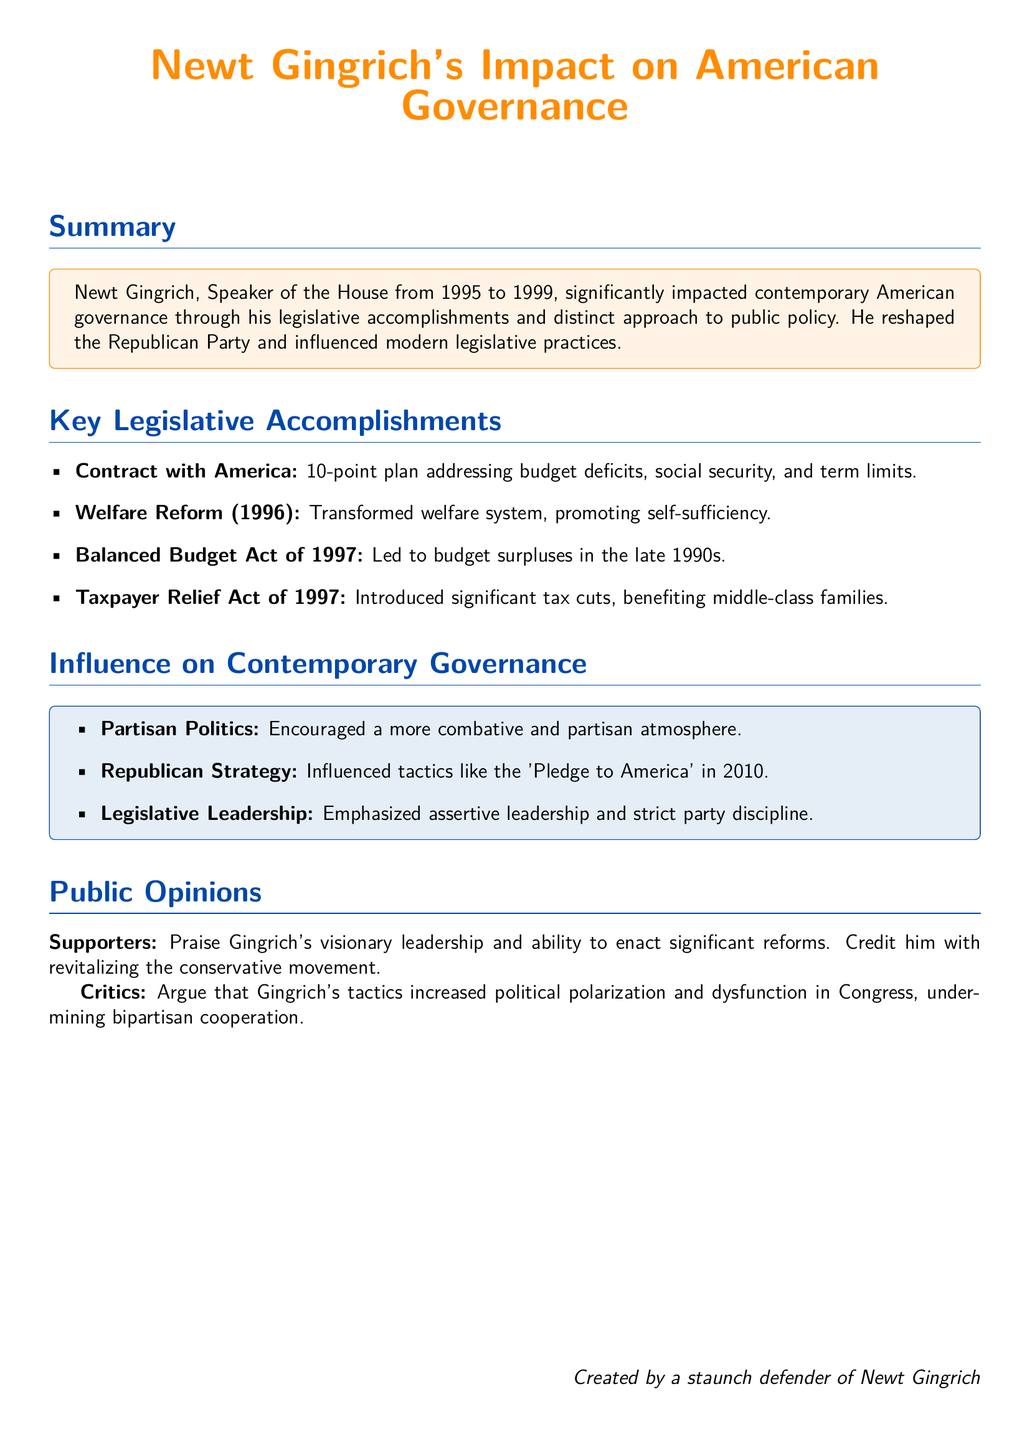What is Newt Gingrich's role? The document states that Newt Gingrich was the Speaker of the House from 1995 to 1999.
Answer: Speaker of the House What is the first legislative accomplishment listed? The first legislative accomplishment mentioned is the "Contract with America", a 10-point plan addressing key issues.
Answer: Contract with America What year was the Welfare Reform enacted? The document specifies that the Welfare Reform was enacted in 1996.
Answer: 1996 What significant act did Gingrich lead in 1997 that contributed to budget surpluses? The document mentions the Balanced Budget Act of 1997 as the significant act that contributed to budget surpluses.
Answer: Balanced Budget Act of 1997 What atmosphere did Gingrich's influence encourage? Gingrich's influence encouraged a more combative and partisan atmosphere in politics.
Answer: combative and partisan What tactics did Gingrich influence in the Republican Strategy? The document states that Gingrich's tactics influenced the "Pledge to America" in 2010.
Answer: Pledge to America How do supporters view Gingrich's contributions? Supporters praise Gingrich for his visionary leadership and ability to enact significant reforms.
Answer: visionary leadership What do critics argue about Gingrich's tactics? Critics argue that Gingrich's tactics increased political polarization and dysfunction in Congress.
Answer: increased polarization What color is used for the title? The title color specified in the document is newtorange.
Answer: newtorange 